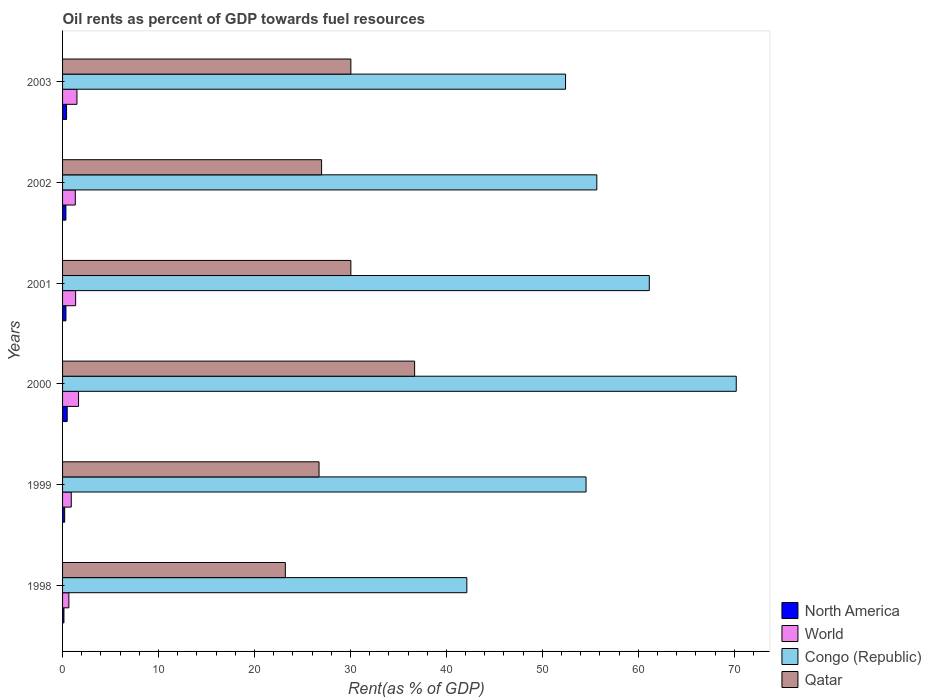How many different coloured bars are there?
Provide a succinct answer. 4. How many bars are there on the 2nd tick from the bottom?
Your response must be concise. 4. What is the oil rent in Qatar in 2001?
Your answer should be compact. 30.05. Across all years, what is the maximum oil rent in Congo (Republic)?
Provide a short and direct response. 70.21. Across all years, what is the minimum oil rent in Qatar?
Ensure brevity in your answer.  23.22. In which year was the oil rent in Congo (Republic) maximum?
Offer a very short reply. 2000. What is the total oil rent in World in the graph?
Your response must be concise. 7.42. What is the difference between the oil rent in North America in 2001 and that in 2002?
Offer a terse response. 0. What is the difference between the oil rent in North America in 2000 and the oil rent in Congo (Republic) in 1999?
Your answer should be compact. -54.07. What is the average oil rent in North America per year?
Offer a very short reply. 0.33. In the year 2000, what is the difference between the oil rent in North America and oil rent in Qatar?
Your response must be concise. -36.21. In how many years, is the oil rent in World greater than 18 %?
Provide a succinct answer. 0. What is the ratio of the oil rent in World in 2000 to that in 2003?
Provide a short and direct response. 1.11. Is the difference between the oil rent in North America in 2001 and 2003 greater than the difference between the oil rent in Qatar in 2001 and 2003?
Provide a short and direct response. No. What is the difference between the highest and the second highest oil rent in World?
Offer a very short reply. 0.17. What is the difference between the highest and the lowest oil rent in Congo (Republic)?
Offer a very short reply. 28.08. In how many years, is the oil rent in Qatar greater than the average oil rent in Qatar taken over all years?
Offer a very short reply. 3. Is it the case that in every year, the sum of the oil rent in World and oil rent in Congo (Republic) is greater than the sum of oil rent in North America and oil rent in Qatar?
Your response must be concise. No. What does the 4th bar from the top in 2001 represents?
Offer a terse response. North America. What does the 2nd bar from the bottom in 2003 represents?
Offer a very short reply. World. How many bars are there?
Give a very brief answer. 24. Are the values on the major ticks of X-axis written in scientific E-notation?
Ensure brevity in your answer.  No. Where does the legend appear in the graph?
Make the answer very short. Bottom right. How many legend labels are there?
Offer a terse response. 4. How are the legend labels stacked?
Keep it short and to the point. Vertical. What is the title of the graph?
Offer a very short reply. Oil rents as percent of GDP towards fuel resources. Does "Niger" appear as one of the legend labels in the graph?
Offer a terse response. No. What is the label or title of the X-axis?
Your answer should be compact. Rent(as % of GDP). What is the label or title of the Y-axis?
Provide a short and direct response. Years. What is the Rent(as % of GDP) of North America in 1998?
Your response must be concise. 0.14. What is the Rent(as % of GDP) in World in 1998?
Give a very brief answer. 0.66. What is the Rent(as % of GDP) of Congo (Republic) in 1998?
Offer a very short reply. 42.13. What is the Rent(as % of GDP) in Qatar in 1998?
Your answer should be compact. 23.22. What is the Rent(as % of GDP) of North America in 1999?
Your answer should be compact. 0.22. What is the Rent(as % of GDP) in World in 1999?
Your answer should be compact. 0.91. What is the Rent(as % of GDP) in Congo (Republic) in 1999?
Provide a succinct answer. 54.56. What is the Rent(as % of GDP) in Qatar in 1999?
Provide a succinct answer. 26.73. What is the Rent(as % of GDP) of North America in 2000?
Offer a terse response. 0.48. What is the Rent(as % of GDP) of World in 2000?
Provide a short and direct response. 1.67. What is the Rent(as % of GDP) in Congo (Republic) in 2000?
Provide a succinct answer. 70.21. What is the Rent(as % of GDP) of Qatar in 2000?
Your response must be concise. 36.69. What is the Rent(as % of GDP) of North America in 2001?
Provide a short and direct response. 0.35. What is the Rent(as % of GDP) of World in 2001?
Ensure brevity in your answer.  1.36. What is the Rent(as % of GDP) of Congo (Republic) in 2001?
Your answer should be very brief. 61.15. What is the Rent(as % of GDP) of Qatar in 2001?
Your answer should be compact. 30.05. What is the Rent(as % of GDP) in North America in 2002?
Offer a very short reply. 0.35. What is the Rent(as % of GDP) in World in 2002?
Your answer should be very brief. 1.33. What is the Rent(as % of GDP) of Congo (Republic) in 2002?
Provide a short and direct response. 55.68. What is the Rent(as % of GDP) of Qatar in 2002?
Provide a succinct answer. 27. What is the Rent(as % of GDP) of North America in 2003?
Give a very brief answer. 0.42. What is the Rent(as % of GDP) of World in 2003?
Ensure brevity in your answer.  1.5. What is the Rent(as % of GDP) in Congo (Republic) in 2003?
Provide a short and direct response. 52.42. What is the Rent(as % of GDP) of Qatar in 2003?
Your response must be concise. 30.05. Across all years, what is the maximum Rent(as % of GDP) of North America?
Provide a succinct answer. 0.48. Across all years, what is the maximum Rent(as % of GDP) in World?
Ensure brevity in your answer.  1.67. Across all years, what is the maximum Rent(as % of GDP) of Congo (Republic)?
Your answer should be very brief. 70.21. Across all years, what is the maximum Rent(as % of GDP) of Qatar?
Keep it short and to the point. 36.69. Across all years, what is the minimum Rent(as % of GDP) in North America?
Offer a terse response. 0.14. Across all years, what is the minimum Rent(as % of GDP) in World?
Provide a succinct answer. 0.66. Across all years, what is the minimum Rent(as % of GDP) in Congo (Republic)?
Your answer should be very brief. 42.13. Across all years, what is the minimum Rent(as % of GDP) of Qatar?
Keep it short and to the point. 23.22. What is the total Rent(as % of GDP) in North America in the graph?
Provide a short and direct response. 1.96. What is the total Rent(as % of GDP) in World in the graph?
Keep it short and to the point. 7.42. What is the total Rent(as % of GDP) in Congo (Republic) in the graph?
Your answer should be very brief. 336.15. What is the total Rent(as % of GDP) of Qatar in the graph?
Make the answer very short. 173.73. What is the difference between the Rent(as % of GDP) in North America in 1998 and that in 1999?
Provide a succinct answer. -0.08. What is the difference between the Rent(as % of GDP) of World in 1998 and that in 1999?
Ensure brevity in your answer.  -0.25. What is the difference between the Rent(as % of GDP) of Congo (Republic) in 1998 and that in 1999?
Provide a succinct answer. -12.42. What is the difference between the Rent(as % of GDP) in Qatar in 1998 and that in 1999?
Ensure brevity in your answer.  -3.51. What is the difference between the Rent(as % of GDP) of North America in 1998 and that in 2000?
Ensure brevity in your answer.  -0.34. What is the difference between the Rent(as % of GDP) in World in 1998 and that in 2000?
Your answer should be very brief. -1.01. What is the difference between the Rent(as % of GDP) of Congo (Republic) in 1998 and that in 2000?
Give a very brief answer. -28.08. What is the difference between the Rent(as % of GDP) in Qatar in 1998 and that in 2000?
Offer a terse response. -13.47. What is the difference between the Rent(as % of GDP) in North America in 1998 and that in 2001?
Offer a terse response. -0.21. What is the difference between the Rent(as % of GDP) of World in 1998 and that in 2001?
Provide a succinct answer. -0.71. What is the difference between the Rent(as % of GDP) in Congo (Republic) in 1998 and that in 2001?
Your answer should be very brief. -19.02. What is the difference between the Rent(as % of GDP) in Qatar in 1998 and that in 2001?
Make the answer very short. -6.83. What is the difference between the Rent(as % of GDP) in North America in 1998 and that in 2002?
Ensure brevity in your answer.  -0.2. What is the difference between the Rent(as % of GDP) in World in 1998 and that in 2002?
Your response must be concise. -0.67. What is the difference between the Rent(as % of GDP) of Congo (Republic) in 1998 and that in 2002?
Keep it short and to the point. -13.55. What is the difference between the Rent(as % of GDP) in Qatar in 1998 and that in 2002?
Provide a succinct answer. -3.78. What is the difference between the Rent(as % of GDP) of North America in 1998 and that in 2003?
Offer a terse response. -0.27. What is the difference between the Rent(as % of GDP) of World in 1998 and that in 2003?
Your response must be concise. -0.84. What is the difference between the Rent(as % of GDP) in Congo (Republic) in 1998 and that in 2003?
Your answer should be compact. -10.29. What is the difference between the Rent(as % of GDP) in Qatar in 1998 and that in 2003?
Give a very brief answer. -6.83. What is the difference between the Rent(as % of GDP) in North America in 1999 and that in 2000?
Offer a terse response. -0.26. What is the difference between the Rent(as % of GDP) of World in 1999 and that in 2000?
Offer a very short reply. -0.76. What is the difference between the Rent(as % of GDP) in Congo (Republic) in 1999 and that in 2000?
Your answer should be very brief. -15.65. What is the difference between the Rent(as % of GDP) in Qatar in 1999 and that in 2000?
Provide a succinct answer. -9.96. What is the difference between the Rent(as % of GDP) in North America in 1999 and that in 2001?
Offer a very short reply. -0.13. What is the difference between the Rent(as % of GDP) in World in 1999 and that in 2001?
Keep it short and to the point. -0.46. What is the difference between the Rent(as % of GDP) in Congo (Republic) in 1999 and that in 2001?
Your answer should be compact. -6.59. What is the difference between the Rent(as % of GDP) in Qatar in 1999 and that in 2001?
Offer a very short reply. -3.32. What is the difference between the Rent(as % of GDP) in North America in 1999 and that in 2002?
Your answer should be very brief. -0.13. What is the difference between the Rent(as % of GDP) in World in 1999 and that in 2002?
Offer a very short reply. -0.42. What is the difference between the Rent(as % of GDP) in Congo (Republic) in 1999 and that in 2002?
Offer a very short reply. -1.12. What is the difference between the Rent(as % of GDP) of Qatar in 1999 and that in 2002?
Offer a very short reply. -0.27. What is the difference between the Rent(as % of GDP) of North America in 1999 and that in 2003?
Provide a short and direct response. -0.2. What is the difference between the Rent(as % of GDP) of World in 1999 and that in 2003?
Your response must be concise. -0.59. What is the difference between the Rent(as % of GDP) in Congo (Republic) in 1999 and that in 2003?
Ensure brevity in your answer.  2.14. What is the difference between the Rent(as % of GDP) of Qatar in 1999 and that in 2003?
Provide a short and direct response. -3.32. What is the difference between the Rent(as % of GDP) in North America in 2000 and that in 2001?
Your answer should be very brief. 0.13. What is the difference between the Rent(as % of GDP) of World in 2000 and that in 2001?
Provide a short and direct response. 0.3. What is the difference between the Rent(as % of GDP) of Congo (Republic) in 2000 and that in 2001?
Your response must be concise. 9.06. What is the difference between the Rent(as % of GDP) of Qatar in 2000 and that in 2001?
Give a very brief answer. 6.65. What is the difference between the Rent(as % of GDP) of North America in 2000 and that in 2002?
Offer a terse response. 0.13. What is the difference between the Rent(as % of GDP) of World in 2000 and that in 2002?
Make the answer very short. 0.34. What is the difference between the Rent(as % of GDP) in Congo (Republic) in 2000 and that in 2002?
Give a very brief answer. 14.53. What is the difference between the Rent(as % of GDP) in Qatar in 2000 and that in 2002?
Provide a short and direct response. 9.7. What is the difference between the Rent(as % of GDP) of North America in 2000 and that in 2003?
Give a very brief answer. 0.06. What is the difference between the Rent(as % of GDP) of World in 2000 and that in 2003?
Your response must be concise. 0.17. What is the difference between the Rent(as % of GDP) of Congo (Republic) in 2000 and that in 2003?
Keep it short and to the point. 17.79. What is the difference between the Rent(as % of GDP) in Qatar in 2000 and that in 2003?
Provide a succinct answer. 6.65. What is the difference between the Rent(as % of GDP) in North America in 2001 and that in 2002?
Ensure brevity in your answer.  0. What is the difference between the Rent(as % of GDP) in World in 2001 and that in 2002?
Make the answer very short. 0.04. What is the difference between the Rent(as % of GDP) in Congo (Republic) in 2001 and that in 2002?
Offer a very short reply. 5.47. What is the difference between the Rent(as % of GDP) of Qatar in 2001 and that in 2002?
Ensure brevity in your answer.  3.05. What is the difference between the Rent(as % of GDP) in North America in 2001 and that in 2003?
Give a very brief answer. -0.07. What is the difference between the Rent(as % of GDP) in World in 2001 and that in 2003?
Your answer should be compact. -0.14. What is the difference between the Rent(as % of GDP) in Congo (Republic) in 2001 and that in 2003?
Your answer should be compact. 8.73. What is the difference between the Rent(as % of GDP) of North America in 2002 and that in 2003?
Offer a terse response. -0.07. What is the difference between the Rent(as % of GDP) in World in 2002 and that in 2003?
Keep it short and to the point. -0.17. What is the difference between the Rent(as % of GDP) of Congo (Republic) in 2002 and that in 2003?
Provide a succinct answer. 3.26. What is the difference between the Rent(as % of GDP) in Qatar in 2002 and that in 2003?
Offer a terse response. -3.05. What is the difference between the Rent(as % of GDP) of North America in 1998 and the Rent(as % of GDP) of World in 1999?
Your answer should be compact. -0.76. What is the difference between the Rent(as % of GDP) of North America in 1998 and the Rent(as % of GDP) of Congo (Republic) in 1999?
Your answer should be very brief. -54.41. What is the difference between the Rent(as % of GDP) in North America in 1998 and the Rent(as % of GDP) in Qatar in 1999?
Your response must be concise. -26.59. What is the difference between the Rent(as % of GDP) of World in 1998 and the Rent(as % of GDP) of Congo (Republic) in 1999?
Keep it short and to the point. -53.9. What is the difference between the Rent(as % of GDP) in World in 1998 and the Rent(as % of GDP) in Qatar in 1999?
Provide a succinct answer. -26.07. What is the difference between the Rent(as % of GDP) in Congo (Republic) in 1998 and the Rent(as % of GDP) in Qatar in 1999?
Offer a terse response. 15.4. What is the difference between the Rent(as % of GDP) of North America in 1998 and the Rent(as % of GDP) of World in 2000?
Make the answer very short. -1.52. What is the difference between the Rent(as % of GDP) in North America in 1998 and the Rent(as % of GDP) in Congo (Republic) in 2000?
Your answer should be very brief. -70.07. What is the difference between the Rent(as % of GDP) of North America in 1998 and the Rent(as % of GDP) of Qatar in 2000?
Ensure brevity in your answer.  -36.55. What is the difference between the Rent(as % of GDP) in World in 1998 and the Rent(as % of GDP) in Congo (Republic) in 2000?
Your response must be concise. -69.55. What is the difference between the Rent(as % of GDP) of World in 1998 and the Rent(as % of GDP) of Qatar in 2000?
Make the answer very short. -36.03. What is the difference between the Rent(as % of GDP) in Congo (Republic) in 1998 and the Rent(as % of GDP) in Qatar in 2000?
Your response must be concise. 5.44. What is the difference between the Rent(as % of GDP) in North America in 1998 and the Rent(as % of GDP) in World in 2001?
Your answer should be compact. -1.22. What is the difference between the Rent(as % of GDP) in North America in 1998 and the Rent(as % of GDP) in Congo (Republic) in 2001?
Keep it short and to the point. -61.01. What is the difference between the Rent(as % of GDP) of North America in 1998 and the Rent(as % of GDP) of Qatar in 2001?
Keep it short and to the point. -29.9. What is the difference between the Rent(as % of GDP) in World in 1998 and the Rent(as % of GDP) in Congo (Republic) in 2001?
Your answer should be very brief. -60.49. What is the difference between the Rent(as % of GDP) in World in 1998 and the Rent(as % of GDP) in Qatar in 2001?
Offer a terse response. -29.39. What is the difference between the Rent(as % of GDP) of Congo (Republic) in 1998 and the Rent(as % of GDP) of Qatar in 2001?
Offer a very short reply. 12.09. What is the difference between the Rent(as % of GDP) in North America in 1998 and the Rent(as % of GDP) in World in 2002?
Your answer should be compact. -1.18. What is the difference between the Rent(as % of GDP) in North America in 1998 and the Rent(as % of GDP) in Congo (Republic) in 2002?
Your answer should be very brief. -55.54. What is the difference between the Rent(as % of GDP) of North America in 1998 and the Rent(as % of GDP) of Qatar in 2002?
Provide a succinct answer. -26.85. What is the difference between the Rent(as % of GDP) of World in 1998 and the Rent(as % of GDP) of Congo (Republic) in 2002?
Make the answer very short. -55.02. What is the difference between the Rent(as % of GDP) of World in 1998 and the Rent(as % of GDP) of Qatar in 2002?
Offer a terse response. -26.34. What is the difference between the Rent(as % of GDP) of Congo (Republic) in 1998 and the Rent(as % of GDP) of Qatar in 2002?
Your answer should be very brief. 15.14. What is the difference between the Rent(as % of GDP) in North America in 1998 and the Rent(as % of GDP) in World in 2003?
Provide a succinct answer. -1.36. What is the difference between the Rent(as % of GDP) in North America in 1998 and the Rent(as % of GDP) in Congo (Republic) in 2003?
Your answer should be compact. -52.28. What is the difference between the Rent(as % of GDP) of North America in 1998 and the Rent(as % of GDP) of Qatar in 2003?
Your answer should be very brief. -29.9. What is the difference between the Rent(as % of GDP) in World in 1998 and the Rent(as % of GDP) in Congo (Republic) in 2003?
Ensure brevity in your answer.  -51.76. What is the difference between the Rent(as % of GDP) in World in 1998 and the Rent(as % of GDP) in Qatar in 2003?
Offer a terse response. -29.39. What is the difference between the Rent(as % of GDP) in Congo (Republic) in 1998 and the Rent(as % of GDP) in Qatar in 2003?
Offer a very short reply. 12.09. What is the difference between the Rent(as % of GDP) of North America in 1999 and the Rent(as % of GDP) of World in 2000?
Make the answer very short. -1.45. What is the difference between the Rent(as % of GDP) in North America in 1999 and the Rent(as % of GDP) in Congo (Republic) in 2000?
Provide a short and direct response. -69.99. What is the difference between the Rent(as % of GDP) in North America in 1999 and the Rent(as % of GDP) in Qatar in 2000?
Provide a short and direct response. -36.47. What is the difference between the Rent(as % of GDP) of World in 1999 and the Rent(as % of GDP) of Congo (Republic) in 2000?
Make the answer very short. -69.3. What is the difference between the Rent(as % of GDP) of World in 1999 and the Rent(as % of GDP) of Qatar in 2000?
Offer a very short reply. -35.79. What is the difference between the Rent(as % of GDP) of Congo (Republic) in 1999 and the Rent(as % of GDP) of Qatar in 2000?
Offer a terse response. 17.86. What is the difference between the Rent(as % of GDP) in North America in 1999 and the Rent(as % of GDP) in World in 2001?
Make the answer very short. -1.14. What is the difference between the Rent(as % of GDP) in North America in 1999 and the Rent(as % of GDP) in Congo (Republic) in 2001?
Give a very brief answer. -60.93. What is the difference between the Rent(as % of GDP) in North America in 1999 and the Rent(as % of GDP) in Qatar in 2001?
Ensure brevity in your answer.  -29.83. What is the difference between the Rent(as % of GDP) of World in 1999 and the Rent(as % of GDP) of Congo (Republic) in 2001?
Provide a succinct answer. -60.24. What is the difference between the Rent(as % of GDP) of World in 1999 and the Rent(as % of GDP) of Qatar in 2001?
Offer a terse response. -29.14. What is the difference between the Rent(as % of GDP) in Congo (Republic) in 1999 and the Rent(as % of GDP) in Qatar in 2001?
Give a very brief answer. 24.51. What is the difference between the Rent(as % of GDP) in North America in 1999 and the Rent(as % of GDP) in World in 2002?
Offer a very short reply. -1.11. What is the difference between the Rent(as % of GDP) of North America in 1999 and the Rent(as % of GDP) of Congo (Republic) in 2002?
Your response must be concise. -55.46. What is the difference between the Rent(as % of GDP) in North America in 1999 and the Rent(as % of GDP) in Qatar in 2002?
Offer a terse response. -26.78. What is the difference between the Rent(as % of GDP) of World in 1999 and the Rent(as % of GDP) of Congo (Republic) in 2002?
Provide a succinct answer. -54.77. What is the difference between the Rent(as % of GDP) of World in 1999 and the Rent(as % of GDP) of Qatar in 2002?
Offer a terse response. -26.09. What is the difference between the Rent(as % of GDP) in Congo (Republic) in 1999 and the Rent(as % of GDP) in Qatar in 2002?
Ensure brevity in your answer.  27.56. What is the difference between the Rent(as % of GDP) of North America in 1999 and the Rent(as % of GDP) of World in 2003?
Your response must be concise. -1.28. What is the difference between the Rent(as % of GDP) of North America in 1999 and the Rent(as % of GDP) of Congo (Republic) in 2003?
Make the answer very short. -52.2. What is the difference between the Rent(as % of GDP) of North America in 1999 and the Rent(as % of GDP) of Qatar in 2003?
Make the answer very short. -29.83. What is the difference between the Rent(as % of GDP) in World in 1999 and the Rent(as % of GDP) in Congo (Republic) in 2003?
Your response must be concise. -51.51. What is the difference between the Rent(as % of GDP) in World in 1999 and the Rent(as % of GDP) in Qatar in 2003?
Offer a very short reply. -29.14. What is the difference between the Rent(as % of GDP) in Congo (Republic) in 1999 and the Rent(as % of GDP) in Qatar in 2003?
Offer a very short reply. 24.51. What is the difference between the Rent(as % of GDP) in North America in 2000 and the Rent(as % of GDP) in World in 2001?
Provide a succinct answer. -0.88. What is the difference between the Rent(as % of GDP) of North America in 2000 and the Rent(as % of GDP) of Congo (Republic) in 2001?
Your answer should be very brief. -60.67. What is the difference between the Rent(as % of GDP) of North America in 2000 and the Rent(as % of GDP) of Qatar in 2001?
Ensure brevity in your answer.  -29.56. What is the difference between the Rent(as % of GDP) in World in 2000 and the Rent(as % of GDP) in Congo (Republic) in 2001?
Ensure brevity in your answer.  -59.48. What is the difference between the Rent(as % of GDP) in World in 2000 and the Rent(as % of GDP) in Qatar in 2001?
Keep it short and to the point. -28.38. What is the difference between the Rent(as % of GDP) of Congo (Republic) in 2000 and the Rent(as % of GDP) of Qatar in 2001?
Provide a short and direct response. 40.16. What is the difference between the Rent(as % of GDP) of North America in 2000 and the Rent(as % of GDP) of World in 2002?
Keep it short and to the point. -0.84. What is the difference between the Rent(as % of GDP) of North America in 2000 and the Rent(as % of GDP) of Congo (Republic) in 2002?
Your answer should be very brief. -55.2. What is the difference between the Rent(as % of GDP) of North America in 2000 and the Rent(as % of GDP) of Qatar in 2002?
Offer a very short reply. -26.51. What is the difference between the Rent(as % of GDP) of World in 2000 and the Rent(as % of GDP) of Congo (Republic) in 2002?
Your answer should be compact. -54.01. What is the difference between the Rent(as % of GDP) in World in 2000 and the Rent(as % of GDP) in Qatar in 2002?
Provide a succinct answer. -25.33. What is the difference between the Rent(as % of GDP) of Congo (Republic) in 2000 and the Rent(as % of GDP) of Qatar in 2002?
Offer a terse response. 43.21. What is the difference between the Rent(as % of GDP) of North America in 2000 and the Rent(as % of GDP) of World in 2003?
Give a very brief answer. -1.02. What is the difference between the Rent(as % of GDP) of North America in 2000 and the Rent(as % of GDP) of Congo (Republic) in 2003?
Your response must be concise. -51.94. What is the difference between the Rent(as % of GDP) in North America in 2000 and the Rent(as % of GDP) in Qatar in 2003?
Keep it short and to the point. -29.56. What is the difference between the Rent(as % of GDP) in World in 2000 and the Rent(as % of GDP) in Congo (Republic) in 2003?
Give a very brief answer. -50.75. What is the difference between the Rent(as % of GDP) of World in 2000 and the Rent(as % of GDP) of Qatar in 2003?
Your answer should be compact. -28.38. What is the difference between the Rent(as % of GDP) of Congo (Republic) in 2000 and the Rent(as % of GDP) of Qatar in 2003?
Keep it short and to the point. 40.16. What is the difference between the Rent(as % of GDP) in North America in 2001 and the Rent(as % of GDP) in World in 2002?
Ensure brevity in your answer.  -0.98. What is the difference between the Rent(as % of GDP) in North America in 2001 and the Rent(as % of GDP) in Congo (Republic) in 2002?
Offer a very short reply. -55.33. What is the difference between the Rent(as % of GDP) in North America in 2001 and the Rent(as % of GDP) in Qatar in 2002?
Provide a short and direct response. -26.64. What is the difference between the Rent(as % of GDP) in World in 2001 and the Rent(as % of GDP) in Congo (Republic) in 2002?
Your answer should be very brief. -54.32. What is the difference between the Rent(as % of GDP) of World in 2001 and the Rent(as % of GDP) of Qatar in 2002?
Provide a succinct answer. -25.63. What is the difference between the Rent(as % of GDP) of Congo (Republic) in 2001 and the Rent(as % of GDP) of Qatar in 2002?
Provide a succinct answer. 34.15. What is the difference between the Rent(as % of GDP) of North America in 2001 and the Rent(as % of GDP) of World in 2003?
Provide a short and direct response. -1.15. What is the difference between the Rent(as % of GDP) of North America in 2001 and the Rent(as % of GDP) of Congo (Republic) in 2003?
Make the answer very short. -52.07. What is the difference between the Rent(as % of GDP) of North America in 2001 and the Rent(as % of GDP) of Qatar in 2003?
Ensure brevity in your answer.  -29.69. What is the difference between the Rent(as % of GDP) in World in 2001 and the Rent(as % of GDP) in Congo (Republic) in 2003?
Make the answer very short. -51.06. What is the difference between the Rent(as % of GDP) in World in 2001 and the Rent(as % of GDP) in Qatar in 2003?
Provide a succinct answer. -28.68. What is the difference between the Rent(as % of GDP) in Congo (Republic) in 2001 and the Rent(as % of GDP) in Qatar in 2003?
Provide a succinct answer. 31.1. What is the difference between the Rent(as % of GDP) in North America in 2002 and the Rent(as % of GDP) in World in 2003?
Your answer should be very brief. -1.15. What is the difference between the Rent(as % of GDP) in North America in 2002 and the Rent(as % of GDP) in Congo (Republic) in 2003?
Your answer should be compact. -52.07. What is the difference between the Rent(as % of GDP) in North America in 2002 and the Rent(as % of GDP) in Qatar in 2003?
Offer a terse response. -29.7. What is the difference between the Rent(as % of GDP) of World in 2002 and the Rent(as % of GDP) of Congo (Republic) in 2003?
Provide a succinct answer. -51.09. What is the difference between the Rent(as % of GDP) of World in 2002 and the Rent(as % of GDP) of Qatar in 2003?
Your answer should be compact. -28.72. What is the difference between the Rent(as % of GDP) of Congo (Republic) in 2002 and the Rent(as % of GDP) of Qatar in 2003?
Make the answer very short. 25.64. What is the average Rent(as % of GDP) of North America per year?
Your answer should be very brief. 0.33. What is the average Rent(as % of GDP) of World per year?
Ensure brevity in your answer.  1.24. What is the average Rent(as % of GDP) of Congo (Republic) per year?
Make the answer very short. 56.02. What is the average Rent(as % of GDP) in Qatar per year?
Your answer should be very brief. 28.95. In the year 1998, what is the difference between the Rent(as % of GDP) of North America and Rent(as % of GDP) of World?
Offer a very short reply. -0.51. In the year 1998, what is the difference between the Rent(as % of GDP) of North America and Rent(as % of GDP) of Congo (Republic)?
Offer a terse response. -41.99. In the year 1998, what is the difference between the Rent(as % of GDP) in North America and Rent(as % of GDP) in Qatar?
Keep it short and to the point. -23.07. In the year 1998, what is the difference between the Rent(as % of GDP) in World and Rent(as % of GDP) in Congo (Republic)?
Offer a terse response. -41.48. In the year 1998, what is the difference between the Rent(as % of GDP) of World and Rent(as % of GDP) of Qatar?
Provide a short and direct response. -22.56. In the year 1998, what is the difference between the Rent(as % of GDP) in Congo (Republic) and Rent(as % of GDP) in Qatar?
Your answer should be very brief. 18.92. In the year 1999, what is the difference between the Rent(as % of GDP) in North America and Rent(as % of GDP) in World?
Your answer should be compact. -0.69. In the year 1999, what is the difference between the Rent(as % of GDP) of North America and Rent(as % of GDP) of Congo (Republic)?
Make the answer very short. -54.34. In the year 1999, what is the difference between the Rent(as % of GDP) of North America and Rent(as % of GDP) of Qatar?
Make the answer very short. -26.51. In the year 1999, what is the difference between the Rent(as % of GDP) of World and Rent(as % of GDP) of Congo (Republic)?
Provide a short and direct response. -53.65. In the year 1999, what is the difference between the Rent(as % of GDP) in World and Rent(as % of GDP) in Qatar?
Offer a terse response. -25.82. In the year 1999, what is the difference between the Rent(as % of GDP) of Congo (Republic) and Rent(as % of GDP) of Qatar?
Your answer should be very brief. 27.83. In the year 2000, what is the difference between the Rent(as % of GDP) of North America and Rent(as % of GDP) of World?
Your response must be concise. -1.19. In the year 2000, what is the difference between the Rent(as % of GDP) of North America and Rent(as % of GDP) of Congo (Republic)?
Provide a short and direct response. -69.73. In the year 2000, what is the difference between the Rent(as % of GDP) of North America and Rent(as % of GDP) of Qatar?
Ensure brevity in your answer.  -36.21. In the year 2000, what is the difference between the Rent(as % of GDP) in World and Rent(as % of GDP) in Congo (Republic)?
Provide a succinct answer. -68.54. In the year 2000, what is the difference between the Rent(as % of GDP) of World and Rent(as % of GDP) of Qatar?
Provide a succinct answer. -35.03. In the year 2000, what is the difference between the Rent(as % of GDP) of Congo (Republic) and Rent(as % of GDP) of Qatar?
Offer a terse response. 33.52. In the year 2001, what is the difference between the Rent(as % of GDP) in North America and Rent(as % of GDP) in World?
Ensure brevity in your answer.  -1.01. In the year 2001, what is the difference between the Rent(as % of GDP) in North America and Rent(as % of GDP) in Congo (Republic)?
Make the answer very short. -60.8. In the year 2001, what is the difference between the Rent(as % of GDP) of North America and Rent(as % of GDP) of Qatar?
Keep it short and to the point. -29.69. In the year 2001, what is the difference between the Rent(as % of GDP) of World and Rent(as % of GDP) of Congo (Republic)?
Your answer should be compact. -59.79. In the year 2001, what is the difference between the Rent(as % of GDP) of World and Rent(as % of GDP) of Qatar?
Your response must be concise. -28.68. In the year 2001, what is the difference between the Rent(as % of GDP) in Congo (Republic) and Rent(as % of GDP) in Qatar?
Give a very brief answer. 31.1. In the year 2002, what is the difference between the Rent(as % of GDP) of North America and Rent(as % of GDP) of World?
Your response must be concise. -0.98. In the year 2002, what is the difference between the Rent(as % of GDP) in North America and Rent(as % of GDP) in Congo (Republic)?
Provide a short and direct response. -55.33. In the year 2002, what is the difference between the Rent(as % of GDP) in North America and Rent(as % of GDP) in Qatar?
Provide a short and direct response. -26.65. In the year 2002, what is the difference between the Rent(as % of GDP) in World and Rent(as % of GDP) in Congo (Republic)?
Give a very brief answer. -54.35. In the year 2002, what is the difference between the Rent(as % of GDP) in World and Rent(as % of GDP) in Qatar?
Keep it short and to the point. -25.67. In the year 2002, what is the difference between the Rent(as % of GDP) of Congo (Republic) and Rent(as % of GDP) of Qatar?
Your response must be concise. 28.68. In the year 2003, what is the difference between the Rent(as % of GDP) of North America and Rent(as % of GDP) of World?
Your response must be concise. -1.08. In the year 2003, what is the difference between the Rent(as % of GDP) of North America and Rent(as % of GDP) of Congo (Republic)?
Offer a very short reply. -52. In the year 2003, what is the difference between the Rent(as % of GDP) of North America and Rent(as % of GDP) of Qatar?
Your answer should be very brief. -29.63. In the year 2003, what is the difference between the Rent(as % of GDP) in World and Rent(as % of GDP) in Congo (Republic)?
Give a very brief answer. -50.92. In the year 2003, what is the difference between the Rent(as % of GDP) in World and Rent(as % of GDP) in Qatar?
Make the answer very short. -28.55. In the year 2003, what is the difference between the Rent(as % of GDP) in Congo (Republic) and Rent(as % of GDP) in Qatar?
Ensure brevity in your answer.  22.38. What is the ratio of the Rent(as % of GDP) of North America in 1998 to that in 1999?
Offer a very short reply. 0.66. What is the ratio of the Rent(as % of GDP) in World in 1998 to that in 1999?
Your response must be concise. 0.72. What is the ratio of the Rent(as % of GDP) in Congo (Republic) in 1998 to that in 1999?
Ensure brevity in your answer.  0.77. What is the ratio of the Rent(as % of GDP) in Qatar in 1998 to that in 1999?
Your response must be concise. 0.87. What is the ratio of the Rent(as % of GDP) of North America in 1998 to that in 2000?
Your answer should be very brief. 0.3. What is the ratio of the Rent(as % of GDP) in World in 1998 to that in 2000?
Your response must be concise. 0.39. What is the ratio of the Rent(as % of GDP) of Congo (Republic) in 1998 to that in 2000?
Give a very brief answer. 0.6. What is the ratio of the Rent(as % of GDP) of Qatar in 1998 to that in 2000?
Ensure brevity in your answer.  0.63. What is the ratio of the Rent(as % of GDP) of North America in 1998 to that in 2001?
Your response must be concise. 0.41. What is the ratio of the Rent(as % of GDP) in World in 1998 to that in 2001?
Provide a succinct answer. 0.48. What is the ratio of the Rent(as % of GDP) in Congo (Republic) in 1998 to that in 2001?
Offer a terse response. 0.69. What is the ratio of the Rent(as % of GDP) of Qatar in 1998 to that in 2001?
Your answer should be compact. 0.77. What is the ratio of the Rent(as % of GDP) of North America in 1998 to that in 2002?
Keep it short and to the point. 0.41. What is the ratio of the Rent(as % of GDP) in World in 1998 to that in 2002?
Provide a short and direct response. 0.5. What is the ratio of the Rent(as % of GDP) of Congo (Republic) in 1998 to that in 2002?
Provide a succinct answer. 0.76. What is the ratio of the Rent(as % of GDP) of Qatar in 1998 to that in 2002?
Your answer should be very brief. 0.86. What is the ratio of the Rent(as % of GDP) in North America in 1998 to that in 2003?
Make the answer very short. 0.35. What is the ratio of the Rent(as % of GDP) of World in 1998 to that in 2003?
Your answer should be compact. 0.44. What is the ratio of the Rent(as % of GDP) of Congo (Republic) in 1998 to that in 2003?
Offer a terse response. 0.8. What is the ratio of the Rent(as % of GDP) of Qatar in 1998 to that in 2003?
Provide a succinct answer. 0.77. What is the ratio of the Rent(as % of GDP) of North America in 1999 to that in 2000?
Your answer should be compact. 0.46. What is the ratio of the Rent(as % of GDP) of World in 1999 to that in 2000?
Provide a succinct answer. 0.54. What is the ratio of the Rent(as % of GDP) in Congo (Republic) in 1999 to that in 2000?
Provide a short and direct response. 0.78. What is the ratio of the Rent(as % of GDP) of Qatar in 1999 to that in 2000?
Your response must be concise. 0.73. What is the ratio of the Rent(as % of GDP) in World in 1999 to that in 2001?
Offer a very short reply. 0.67. What is the ratio of the Rent(as % of GDP) in Congo (Republic) in 1999 to that in 2001?
Offer a very short reply. 0.89. What is the ratio of the Rent(as % of GDP) in Qatar in 1999 to that in 2001?
Make the answer very short. 0.89. What is the ratio of the Rent(as % of GDP) of North America in 1999 to that in 2002?
Your answer should be compact. 0.63. What is the ratio of the Rent(as % of GDP) of World in 1999 to that in 2002?
Provide a short and direct response. 0.68. What is the ratio of the Rent(as % of GDP) of Congo (Republic) in 1999 to that in 2002?
Provide a short and direct response. 0.98. What is the ratio of the Rent(as % of GDP) of North America in 1999 to that in 2003?
Your answer should be compact. 0.53. What is the ratio of the Rent(as % of GDP) in World in 1999 to that in 2003?
Your answer should be compact. 0.6. What is the ratio of the Rent(as % of GDP) in Congo (Republic) in 1999 to that in 2003?
Offer a very short reply. 1.04. What is the ratio of the Rent(as % of GDP) in Qatar in 1999 to that in 2003?
Your answer should be very brief. 0.89. What is the ratio of the Rent(as % of GDP) in North America in 2000 to that in 2001?
Your answer should be compact. 1.37. What is the ratio of the Rent(as % of GDP) of World in 2000 to that in 2001?
Offer a terse response. 1.22. What is the ratio of the Rent(as % of GDP) of Congo (Republic) in 2000 to that in 2001?
Provide a succinct answer. 1.15. What is the ratio of the Rent(as % of GDP) of Qatar in 2000 to that in 2001?
Offer a terse response. 1.22. What is the ratio of the Rent(as % of GDP) in North America in 2000 to that in 2002?
Make the answer very short. 1.38. What is the ratio of the Rent(as % of GDP) of World in 2000 to that in 2002?
Keep it short and to the point. 1.26. What is the ratio of the Rent(as % of GDP) of Congo (Republic) in 2000 to that in 2002?
Ensure brevity in your answer.  1.26. What is the ratio of the Rent(as % of GDP) of Qatar in 2000 to that in 2002?
Keep it short and to the point. 1.36. What is the ratio of the Rent(as % of GDP) of North America in 2000 to that in 2003?
Your answer should be compact. 1.16. What is the ratio of the Rent(as % of GDP) of World in 2000 to that in 2003?
Offer a terse response. 1.11. What is the ratio of the Rent(as % of GDP) of Congo (Republic) in 2000 to that in 2003?
Provide a succinct answer. 1.34. What is the ratio of the Rent(as % of GDP) of Qatar in 2000 to that in 2003?
Offer a very short reply. 1.22. What is the ratio of the Rent(as % of GDP) of North America in 2001 to that in 2002?
Provide a short and direct response. 1.01. What is the ratio of the Rent(as % of GDP) of World in 2001 to that in 2002?
Give a very brief answer. 1.03. What is the ratio of the Rent(as % of GDP) in Congo (Republic) in 2001 to that in 2002?
Provide a short and direct response. 1.1. What is the ratio of the Rent(as % of GDP) of Qatar in 2001 to that in 2002?
Make the answer very short. 1.11. What is the ratio of the Rent(as % of GDP) in North America in 2001 to that in 2003?
Make the answer very short. 0.84. What is the ratio of the Rent(as % of GDP) of World in 2001 to that in 2003?
Offer a terse response. 0.91. What is the ratio of the Rent(as % of GDP) of Congo (Republic) in 2001 to that in 2003?
Provide a succinct answer. 1.17. What is the ratio of the Rent(as % of GDP) in Qatar in 2001 to that in 2003?
Keep it short and to the point. 1. What is the ratio of the Rent(as % of GDP) of North America in 2002 to that in 2003?
Give a very brief answer. 0.84. What is the ratio of the Rent(as % of GDP) in World in 2002 to that in 2003?
Offer a very short reply. 0.88. What is the ratio of the Rent(as % of GDP) in Congo (Republic) in 2002 to that in 2003?
Your answer should be very brief. 1.06. What is the ratio of the Rent(as % of GDP) of Qatar in 2002 to that in 2003?
Give a very brief answer. 0.9. What is the difference between the highest and the second highest Rent(as % of GDP) of North America?
Offer a terse response. 0.06. What is the difference between the highest and the second highest Rent(as % of GDP) in World?
Offer a terse response. 0.17. What is the difference between the highest and the second highest Rent(as % of GDP) of Congo (Republic)?
Provide a short and direct response. 9.06. What is the difference between the highest and the second highest Rent(as % of GDP) of Qatar?
Offer a terse response. 6.65. What is the difference between the highest and the lowest Rent(as % of GDP) in North America?
Keep it short and to the point. 0.34. What is the difference between the highest and the lowest Rent(as % of GDP) of World?
Your response must be concise. 1.01. What is the difference between the highest and the lowest Rent(as % of GDP) of Congo (Republic)?
Offer a very short reply. 28.08. What is the difference between the highest and the lowest Rent(as % of GDP) in Qatar?
Ensure brevity in your answer.  13.47. 